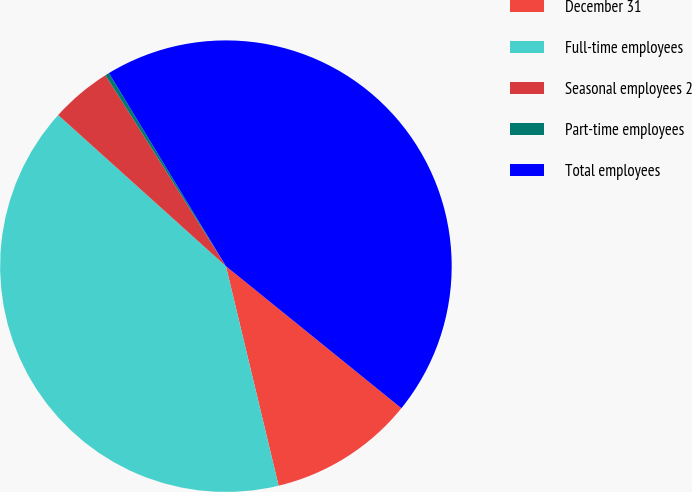<chart> <loc_0><loc_0><loc_500><loc_500><pie_chart><fcel>December 31<fcel>Full-time employees<fcel>Seasonal employees 2<fcel>Part-time employees<fcel>Total employees<nl><fcel>10.42%<fcel>40.42%<fcel>4.37%<fcel>0.29%<fcel>44.5%<nl></chart> 